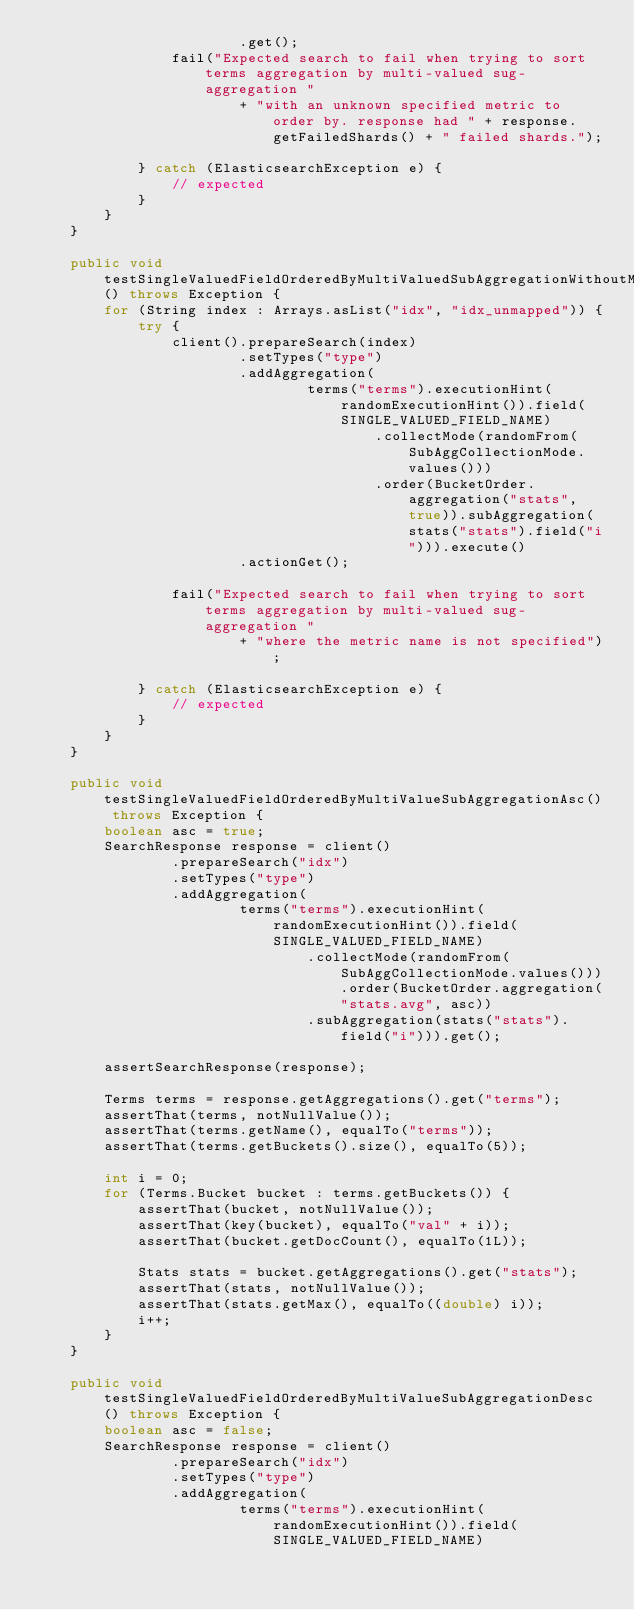<code> <loc_0><loc_0><loc_500><loc_500><_Java_>                        .get();
                fail("Expected search to fail when trying to sort terms aggregation by multi-valued sug-aggregation "
                        + "with an unknown specified metric to order by. response had " + response.getFailedShards() + " failed shards.");

            } catch (ElasticsearchException e) {
                // expected
            }
        }
    }

    public void testSingleValuedFieldOrderedByMultiValuedSubAggregationWithoutMetric() throws Exception {
        for (String index : Arrays.asList("idx", "idx_unmapped")) {
            try {
                client().prepareSearch(index)
                        .setTypes("type")
                        .addAggregation(
                                terms("terms").executionHint(randomExecutionHint()).field(SINGLE_VALUED_FIELD_NAME)
                                        .collectMode(randomFrom(SubAggCollectionMode.values()))
                                        .order(BucketOrder.aggregation("stats", true)).subAggregation(stats("stats").field("i"))).execute()
                        .actionGet();

                fail("Expected search to fail when trying to sort terms aggregation by multi-valued sug-aggregation "
                        + "where the metric name is not specified");

            } catch (ElasticsearchException e) {
                // expected
            }
        }
    }

    public void testSingleValuedFieldOrderedByMultiValueSubAggregationAsc() throws Exception {
        boolean asc = true;
        SearchResponse response = client()
                .prepareSearch("idx")
                .setTypes("type")
                .addAggregation(
                        terms("terms").executionHint(randomExecutionHint()).field(SINGLE_VALUED_FIELD_NAME)
                                .collectMode(randomFrom(SubAggCollectionMode.values())).order(BucketOrder.aggregation("stats.avg", asc))
                                .subAggregation(stats("stats").field("i"))).get();

        assertSearchResponse(response);

        Terms terms = response.getAggregations().get("terms");
        assertThat(terms, notNullValue());
        assertThat(terms.getName(), equalTo("terms"));
        assertThat(terms.getBuckets().size(), equalTo(5));

        int i = 0;
        for (Terms.Bucket bucket : terms.getBuckets()) {
            assertThat(bucket, notNullValue());
            assertThat(key(bucket), equalTo("val" + i));
            assertThat(bucket.getDocCount(), equalTo(1L));

            Stats stats = bucket.getAggregations().get("stats");
            assertThat(stats, notNullValue());
            assertThat(stats.getMax(), equalTo((double) i));
            i++;
        }
    }

    public void testSingleValuedFieldOrderedByMultiValueSubAggregationDesc() throws Exception {
        boolean asc = false;
        SearchResponse response = client()
                .prepareSearch("idx")
                .setTypes("type")
                .addAggregation(
                        terms("terms").executionHint(randomExecutionHint()).field(SINGLE_VALUED_FIELD_NAME)</code> 